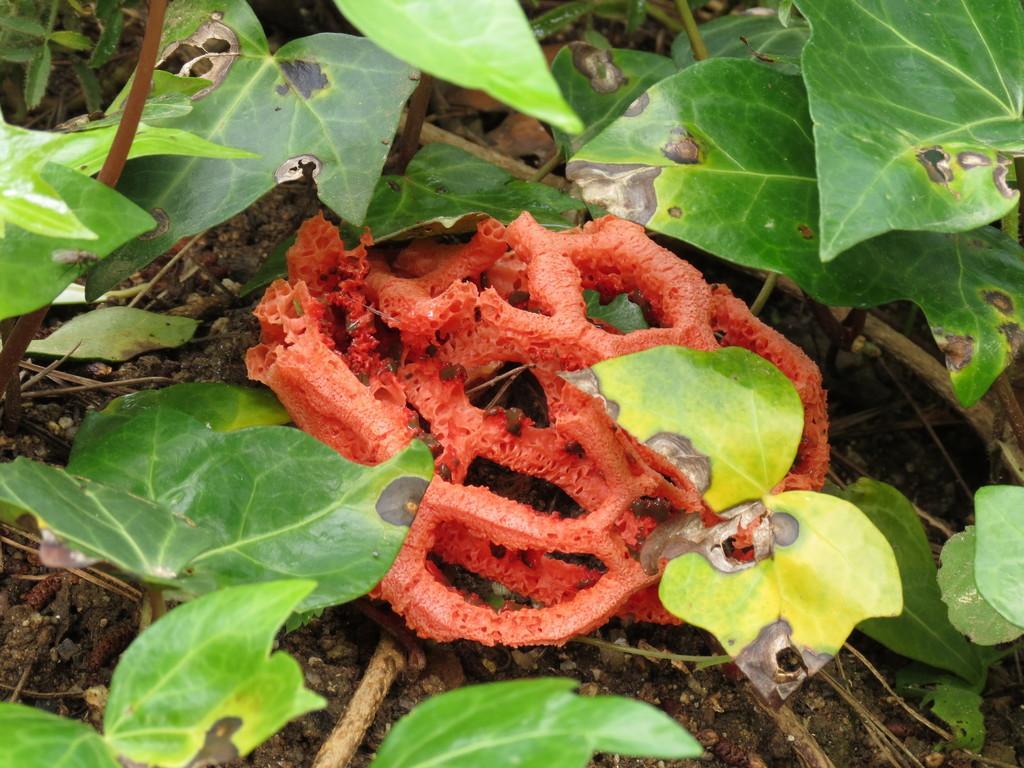Describe this image in one or two sentences. In this image we can see a fungus. There are few plants in the image. 